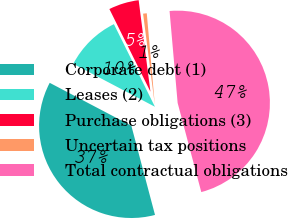<chart> <loc_0><loc_0><loc_500><loc_500><pie_chart><fcel>Corporate debt (1)<fcel>Leases (2)<fcel>Purchase obligations (3)<fcel>Uncertain tax positions<fcel>Total contractual obligations<nl><fcel>36.83%<fcel>9.96%<fcel>5.3%<fcel>0.64%<fcel>47.27%<nl></chart> 